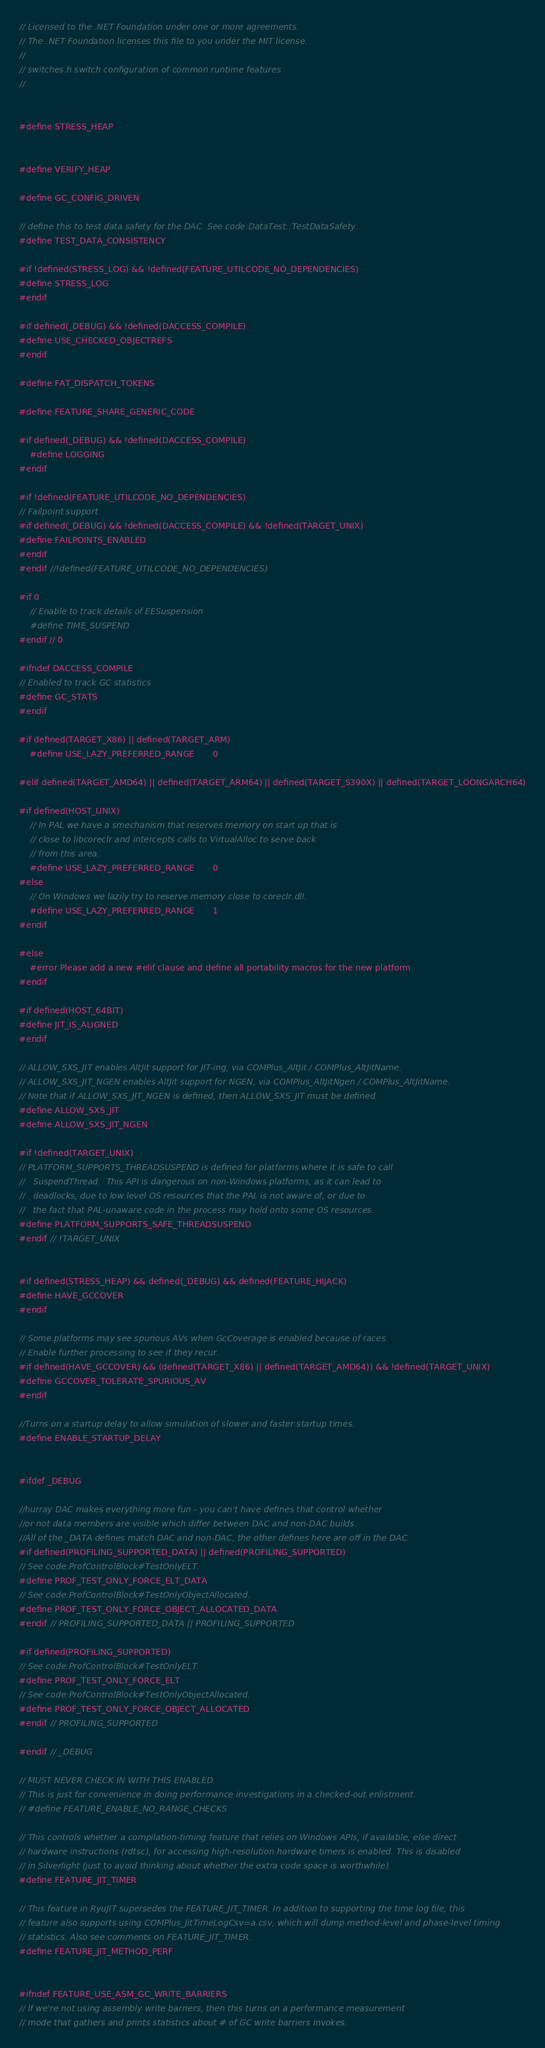<code> <loc_0><loc_0><loc_500><loc_500><_C_>// Licensed to the .NET Foundation under one or more agreements.
// The .NET Foundation licenses this file to you under the MIT license.
//
// switches.h switch configuration of common runtime features
//


#define STRESS_HEAP


#define VERIFY_HEAP

#define GC_CONFIG_DRIVEN

// define this to test data safety for the DAC. See code:DataTest::TestDataSafety.
#define TEST_DATA_CONSISTENCY

#if !defined(STRESS_LOG) && !defined(FEATURE_UTILCODE_NO_DEPENDENCIES)
#define STRESS_LOG
#endif

#if defined(_DEBUG) && !defined(DACCESS_COMPILE)
#define USE_CHECKED_OBJECTREFS
#endif

#define FAT_DISPATCH_TOKENS

#define FEATURE_SHARE_GENERIC_CODE

#if defined(_DEBUG) && !defined(DACCESS_COMPILE)
    #define LOGGING
#endif

#if !defined(FEATURE_UTILCODE_NO_DEPENDENCIES)
// Failpoint support
#if defined(_DEBUG) && !defined(DACCESS_COMPILE) && !defined(TARGET_UNIX)
#define FAILPOINTS_ENABLED
#endif
#endif //!defined(FEATURE_UTILCODE_NO_DEPENDENCIES)

#if 0
    // Enable to track details of EESuspension
    #define TIME_SUSPEND
#endif // 0

#ifndef DACCESS_COMPILE
// Enabled to track GC statistics
#define GC_STATS
#endif

#if defined(TARGET_X86) || defined(TARGET_ARM)
    #define USE_LAZY_PREFERRED_RANGE       0

#elif defined(TARGET_AMD64) || defined(TARGET_ARM64) || defined(TARGET_S390X) || defined(TARGET_LOONGARCH64)

#if defined(HOST_UNIX)
    // In PAL we have a smechanism that reserves memory on start up that is
    // close to libcoreclr and intercepts calls to VirtualAlloc to serve back
    // from this area.
    #define USE_LAZY_PREFERRED_RANGE       0
#else
    // On Windows we lazily try to reserve memory close to coreclr.dll.
    #define USE_LAZY_PREFERRED_RANGE       1
#endif

#else
    #error Please add a new #elif clause and define all portability macros for the new platform
#endif

#if defined(HOST_64BIT)
#define JIT_IS_ALIGNED
#endif

// ALLOW_SXS_JIT enables AltJit support for JIT-ing, via COMPlus_AltJit / COMPlus_AltJitName.
// ALLOW_SXS_JIT_NGEN enables AltJit support for NGEN, via COMPlus_AltJitNgen / COMPlus_AltJitName.
// Note that if ALLOW_SXS_JIT_NGEN is defined, then ALLOW_SXS_JIT must be defined.
#define ALLOW_SXS_JIT
#define ALLOW_SXS_JIT_NGEN

#if !defined(TARGET_UNIX)
// PLATFORM_SUPPORTS_THREADSUSPEND is defined for platforms where it is safe to call
//   SuspendThread.  This API is dangerous on non-Windows platforms, as it can lead to
//   deadlocks, due to low level OS resources that the PAL is not aware of, or due to
//   the fact that PAL-unaware code in the process may hold onto some OS resources.
#define PLATFORM_SUPPORTS_SAFE_THREADSUSPEND
#endif // !TARGET_UNIX


#if defined(STRESS_HEAP) && defined(_DEBUG) && defined(FEATURE_HIJACK)
#define HAVE_GCCOVER
#endif

// Some platforms may see spurious AVs when GcCoverage is enabled because of races.
// Enable further processing to see if they recur.
#if defined(HAVE_GCCOVER) && (defined(TARGET_X86) || defined(TARGET_AMD64)) && !defined(TARGET_UNIX)
#define GCCOVER_TOLERATE_SPURIOUS_AV
#endif

//Turns on a startup delay to allow simulation of slower and faster startup times.
#define ENABLE_STARTUP_DELAY


#ifdef _DEBUG

//hurray DAC makes everything more fun - you can't have defines that control whether
//or not data members are visible which differ between DAC and non-DAC builds.
//All of the _DATA defines match DAC and non-DAC, the other defines here are off in the DAC.
#if defined(PROFILING_SUPPORTED_DATA) || defined(PROFILING_SUPPORTED)
// See code:ProfControlBlock#TestOnlyELT.
#define PROF_TEST_ONLY_FORCE_ELT_DATA
// See code:ProfControlBlock#TestOnlyObjectAllocated.
#define PROF_TEST_ONLY_FORCE_OBJECT_ALLOCATED_DATA
#endif // PROFILING_SUPPORTED_DATA || PROFILING_SUPPORTED

#if defined(PROFILING_SUPPORTED)
// See code:ProfControlBlock#TestOnlyELT.
#define PROF_TEST_ONLY_FORCE_ELT
// See code:ProfControlBlock#TestOnlyObjectAllocated.
#define PROF_TEST_ONLY_FORCE_OBJECT_ALLOCATED
#endif // PROFILING_SUPPORTED

#endif // _DEBUG

// MUST NEVER CHECK IN WITH THIS ENABLED.
// This is just for convenience in doing performance investigations in a checked-out enlistment.
// #define FEATURE_ENABLE_NO_RANGE_CHECKS

// This controls whether a compilation-timing feature that relies on Windows APIs, if available, else direct
// hardware instructions (rdtsc), for accessing high-resolution hardware timers is enabled. This is disabled
// in Silverlight (just to avoid thinking about whether the extra code space is worthwhile).
#define FEATURE_JIT_TIMER

// This feature in RyuJIT supersedes the FEATURE_JIT_TIMER. In addition to supporting the time log file, this
// feature also supports using COMPlus_JitTimeLogCsv=a.csv, which will dump method-level and phase-level timing
// statistics. Also see comments on FEATURE_JIT_TIMER.
#define FEATURE_JIT_METHOD_PERF


#ifndef FEATURE_USE_ASM_GC_WRITE_BARRIERS
// If we're not using assembly write barriers, then this turns on a performance measurement
// mode that gathers and prints statistics about # of GC write barriers invokes.</code> 